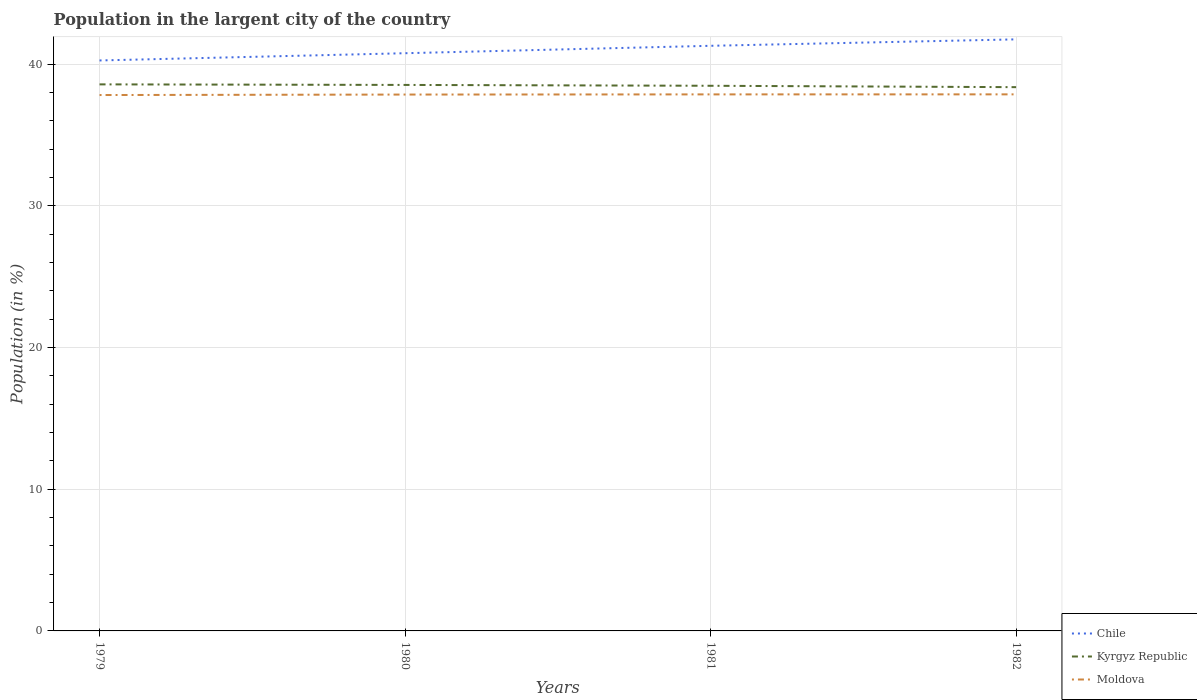How many different coloured lines are there?
Offer a very short reply. 3. Does the line corresponding to Moldova intersect with the line corresponding to Kyrgyz Republic?
Ensure brevity in your answer.  No. Is the number of lines equal to the number of legend labels?
Make the answer very short. Yes. Across all years, what is the maximum percentage of population in the largent city in Kyrgyz Republic?
Your answer should be very brief. 38.37. In which year was the percentage of population in the largent city in Moldova maximum?
Your response must be concise. 1979. What is the total percentage of population in the largent city in Chile in the graph?
Your answer should be very brief. -1.49. What is the difference between the highest and the second highest percentage of population in the largent city in Moldova?
Make the answer very short. 0.05. What is the difference between the highest and the lowest percentage of population in the largent city in Chile?
Ensure brevity in your answer.  2. Is the percentage of population in the largent city in Moldova strictly greater than the percentage of population in the largent city in Chile over the years?
Provide a succinct answer. Yes. How many lines are there?
Provide a short and direct response. 3. How many years are there in the graph?
Your response must be concise. 4. What is the difference between two consecutive major ticks on the Y-axis?
Provide a short and direct response. 10. Are the values on the major ticks of Y-axis written in scientific E-notation?
Your answer should be compact. No. Does the graph contain any zero values?
Your answer should be very brief. No. Where does the legend appear in the graph?
Make the answer very short. Bottom right. How many legend labels are there?
Your response must be concise. 3. How are the legend labels stacked?
Give a very brief answer. Vertical. What is the title of the graph?
Provide a succinct answer. Population in the largent city of the country. What is the label or title of the X-axis?
Your response must be concise. Years. What is the label or title of the Y-axis?
Offer a terse response. Population (in %). What is the Population (in %) in Chile in 1979?
Your answer should be compact. 40.25. What is the Population (in %) of Kyrgyz Republic in 1979?
Give a very brief answer. 38.57. What is the Population (in %) in Moldova in 1979?
Keep it short and to the point. 37.81. What is the Population (in %) of Chile in 1980?
Provide a short and direct response. 40.76. What is the Population (in %) in Kyrgyz Republic in 1980?
Your response must be concise. 38.53. What is the Population (in %) of Moldova in 1980?
Offer a very short reply. 37.85. What is the Population (in %) of Chile in 1981?
Provide a succinct answer. 41.29. What is the Population (in %) of Kyrgyz Republic in 1981?
Keep it short and to the point. 38.47. What is the Population (in %) of Moldova in 1981?
Your answer should be compact. 37.86. What is the Population (in %) in Chile in 1982?
Ensure brevity in your answer.  41.74. What is the Population (in %) of Kyrgyz Republic in 1982?
Offer a terse response. 38.37. What is the Population (in %) in Moldova in 1982?
Your answer should be compact. 37.86. Across all years, what is the maximum Population (in %) of Chile?
Provide a succinct answer. 41.74. Across all years, what is the maximum Population (in %) in Kyrgyz Republic?
Ensure brevity in your answer.  38.57. Across all years, what is the maximum Population (in %) in Moldova?
Offer a very short reply. 37.86. Across all years, what is the minimum Population (in %) of Chile?
Offer a very short reply. 40.25. Across all years, what is the minimum Population (in %) of Kyrgyz Republic?
Make the answer very short. 38.37. Across all years, what is the minimum Population (in %) in Moldova?
Your response must be concise. 37.81. What is the total Population (in %) of Chile in the graph?
Provide a short and direct response. 164.05. What is the total Population (in %) in Kyrgyz Republic in the graph?
Your response must be concise. 153.93. What is the total Population (in %) of Moldova in the graph?
Your answer should be very brief. 151.38. What is the difference between the Population (in %) of Chile in 1979 and that in 1980?
Your answer should be very brief. -0.51. What is the difference between the Population (in %) in Kyrgyz Republic in 1979 and that in 1980?
Give a very brief answer. 0.04. What is the difference between the Population (in %) in Moldova in 1979 and that in 1980?
Give a very brief answer. -0.03. What is the difference between the Population (in %) in Chile in 1979 and that in 1981?
Ensure brevity in your answer.  -1.03. What is the difference between the Population (in %) in Kyrgyz Republic in 1979 and that in 1981?
Your answer should be compact. 0.1. What is the difference between the Population (in %) of Moldova in 1979 and that in 1981?
Make the answer very short. -0.05. What is the difference between the Population (in %) in Chile in 1979 and that in 1982?
Provide a succinct answer. -1.49. What is the difference between the Population (in %) in Kyrgyz Republic in 1979 and that in 1982?
Provide a succinct answer. 0.2. What is the difference between the Population (in %) of Moldova in 1979 and that in 1982?
Give a very brief answer. -0.05. What is the difference between the Population (in %) of Chile in 1980 and that in 1981?
Keep it short and to the point. -0.52. What is the difference between the Population (in %) of Kyrgyz Republic in 1980 and that in 1981?
Keep it short and to the point. 0.06. What is the difference between the Population (in %) in Moldova in 1980 and that in 1981?
Your answer should be compact. -0.01. What is the difference between the Population (in %) of Chile in 1980 and that in 1982?
Provide a succinct answer. -0.98. What is the difference between the Population (in %) in Kyrgyz Republic in 1980 and that in 1982?
Make the answer very short. 0.16. What is the difference between the Population (in %) in Moldova in 1980 and that in 1982?
Give a very brief answer. -0.01. What is the difference between the Population (in %) in Chile in 1981 and that in 1982?
Provide a short and direct response. -0.45. What is the difference between the Population (in %) in Kyrgyz Republic in 1981 and that in 1982?
Provide a short and direct response. 0.1. What is the difference between the Population (in %) in Moldova in 1981 and that in 1982?
Your answer should be very brief. -0. What is the difference between the Population (in %) in Chile in 1979 and the Population (in %) in Kyrgyz Republic in 1980?
Your answer should be compact. 1.73. What is the difference between the Population (in %) in Chile in 1979 and the Population (in %) in Moldova in 1980?
Provide a succinct answer. 2.41. What is the difference between the Population (in %) in Kyrgyz Republic in 1979 and the Population (in %) in Moldova in 1980?
Offer a terse response. 0.72. What is the difference between the Population (in %) of Chile in 1979 and the Population (in %) of Kyrgyz Republic in 1981?
Give a very brief answer. 1.79. What is the difference between the Population (in %) in Chile in 1979 and the Population (in %) in Moldova in 1981?
Provide a short and direct response. 2.39. What is the difference between the Population (in %) of Kyrgyz Republic in 1979 and the Population (in %) of Moldova in 1981?
Offer a terse response. 0.71. What is the difference between the Population (in %) in Chile in 1979 and the Population (in %) in Kyrgyz Republic in 1982?
Provide a succinct answer. 1.88. What is the difference between the Population (in %) in Chile in 1979 and the Population (in %) in Moldova in 1982?
Your response must be concise. 2.39. What is the difference between the Population (in %) in Kyrgyz Republic in 1979 and the Population (in %) in Moldova in 1982?
Provide a succinct answer. 0.71. What is the difference between the Population (in %) of Chile in 1980 and the Population (in %) of Kyrgyz Republic in 1981?
Give a very brief answer. 2.3. What is the difference between the Population (in %) in Chile in 1980 and the Population (in %) in Moldova in 1981?
Offer a very short reply. 2.91. What is the difference between the Population (in %) of Kyrgyz Republic in 1980 and the Population (in %) of Moldova in 1981?
Give a very brief answer. 0.67. What is the difference between the Population (in %) of Chile in 1980 and the Population (in %) of Kyrgyz Republic in 1982?
Your response must be concise. 2.4. What is the difference between the Population (in %) of Chile in 1980 and the Population (in %) of Moldova in 1982?
Your answer should be compact. 2.9. What is the difference between the Population (in %) of Kyrgyz Republic in 1980 and the Population (in %) of Moldova in 1982?
Offer a terse response. 0.67. What is the difference between the Population (in %) of Chile in 1981 and the Population (in %) of Kyrgyz Republic in 1982?
Offer a very short reply. 2.92. What is the difference between the Population (in %) in Chile in 1981 and the Population (in %) in Moldova in 1982?
Your answer should be compact. 3.43. What is the difference between the Population (in %) of Kyrgyz Republic in 1981 and the Population (in %) of Moldova in 1982?
Provide a succinct answer. 0.61. What is the average Population (in %) of Chile per year?
Offer a terse response. 41.01. What is the average Population (in %) in Kyrgyz Republic per year?
Provide a short and direct response. 38.48. What is the average Population (in %) of Moldova per year?
Your response must be concise. 37.85. In the year 1979, what is the difference between the Population (in %) of Chile and Population (in %) of Kyrgyz Republic?
Offer a very short reply. 1.69. In the year 1979, what is the difference between the Population (in %) in Chile and Population (in %) in Moldova?
Ensure brevity in your answer.  2.44. In the year 1979, what is the difference between the Population (in %) in Kyrgyz Republic and Population (in %) in Moldova?
Provide a succinct answer. 0.75. In the year 1980, what is the difference between the Population (in %) of Chile and Population (in %) of Kyrgyz Republic?
Offer a terse response. 2.24. In the year 1980, what is the difference between the Population (in %) in Chile and Population (in %) in Moldova?
Ensure brevity in your answer.  2.92. In the year 1980, what is the difference between the Population (in %) of Kyrgyz Republic and Population (in %) of Moldova?
Your answer should be compact. 0.68. In the year 1981, what is the difference between the Population (in %) in Chile and Population (in %) in Kyrgyz Republic?
Provide a succinct answer. 2.82. In the year 1981, what is the difference between the Population (in %) in Chile and Population (in %) in Moldova?
Your answer should be very brief. 3.43. In the year 1981, what is the difference between the Population (in %) in Kyrgyz Republic and Population (in %) in Moldova?
Your answer should be compact. 0.61. In the year 1982, what is the difference between the Population (in %) in Chile and Population (in %) in Kyrgyz Republic?
Your answer should be very brief. 3.37. In the year 1982, what is the difference between the Population (in %) in Chile and Population (in %) in Moldova?
Your answer should be very brief. 3.88. In the year 1982, what is the difference between the Population (in %) of Kyrgyz Republic and Population (in %) of Moldova?
Keep it short and to the point. 0.51. What is the ratio of the Population (in %) of Chile in 1979 to that in 1980?
Your answer should be compact. 0.99. What is the ratio of the Population (in %) in Kyrgyz Republic in 1979 to that in 1980?
Keep it short and to the point. 1. What is the ratio of the Population (in %) in Moldova in 1979 to that in 1980?
Offer a terse response. 1. What is the ratio of the Population (in %) of Chile in 1979 to that in 1981?
Your answer should be very brief. 0.97. What is the ratio of the Population (in %) in Moldova in 1979 to that in 1981?
Provide a short and direct response. 1. What is the ratio of the Population (in %) of Chile in 1979 to that in 1982?
Give a very brief answer. 0.96. What is the ratio of the Population (in %) in Chile in 1980 to that in 1981?
Ensure brevity in your answer.  0.99. What is the ratio of the Population (in %) in Kyrgyz Republic in 1980 to that in 1981?
Offer a very short reply. 1. What is the ratio of the Population (in %) of Moldova in 1980 to that in 1981?
Your answer should be compact. 1. What is the ratio of the Population (in %) of Chile in 1980 to that in 1982?
Keep it short and to the point. 0.98. What is the ratio of the Population (in %) in Moldova in 1980 to that in 1982?
Ensure brevity in your answer.  1. What is the difference between the highest and the second highest Population (in %) in Chile?
Provide a succinct answer. 0.45. What is the difference between the highest and the second highest Population (in %) in Kyrgyz Republic?
Ensure brevity in your answer.  0.04. What is the difference between the highest and the second highest Population (in %) of Moldova?
Make the answer very short. 0. What is the difference between the highest and the lowest Population (in %) in Chile?
Make the answer very short. 1.49. What is the difference between the highest and the lowest Population (in %) of Kyrgyz Republic?
Keep it short and to the point. 0.2. What is the difference between the highest and the lowest Population (in %) of Moldova?
Provide a succinct answer. 0.05. 